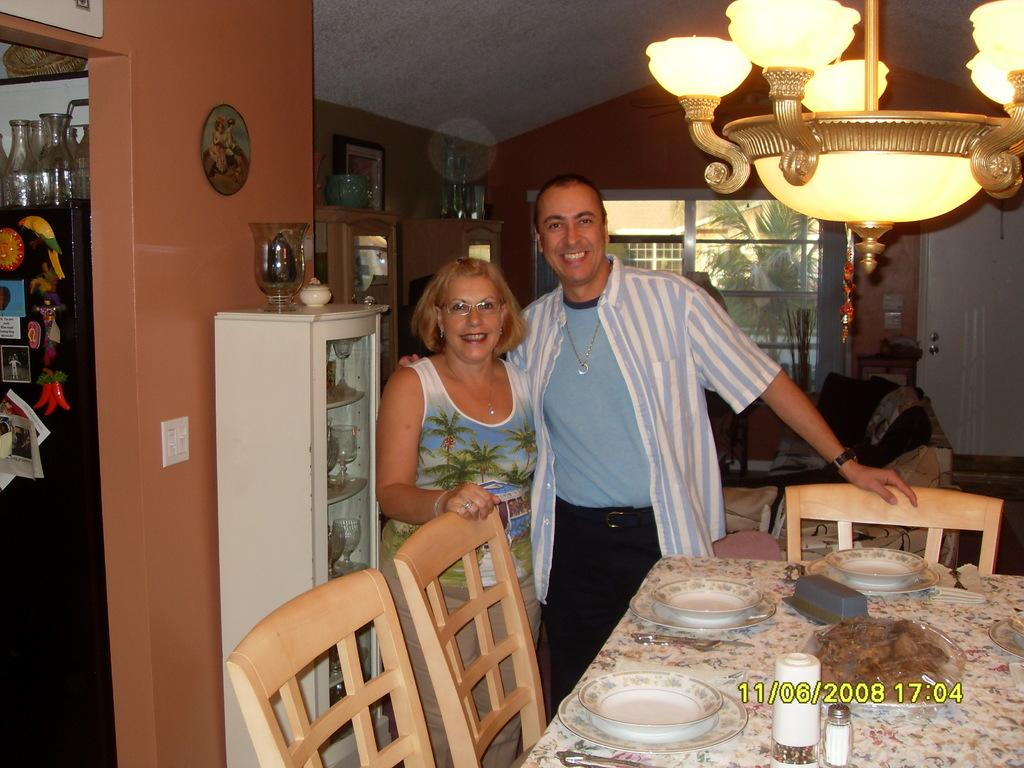How many people are in the image? There is a woman and a man in the image. What are the expressions on their faces? Both the woman and the man are smiling. What type of furniture is present in the image? There is a dining table and chairs near the dining table. What is on the dining table? There are view plates on the dining table. Can you describe the lighting in the image? There is a light visible in the image. What type of island can be seen in the image? There is no island present in the image. What are the people in the image using to cut something? There are no scissors or cutting tools visible in the image. 